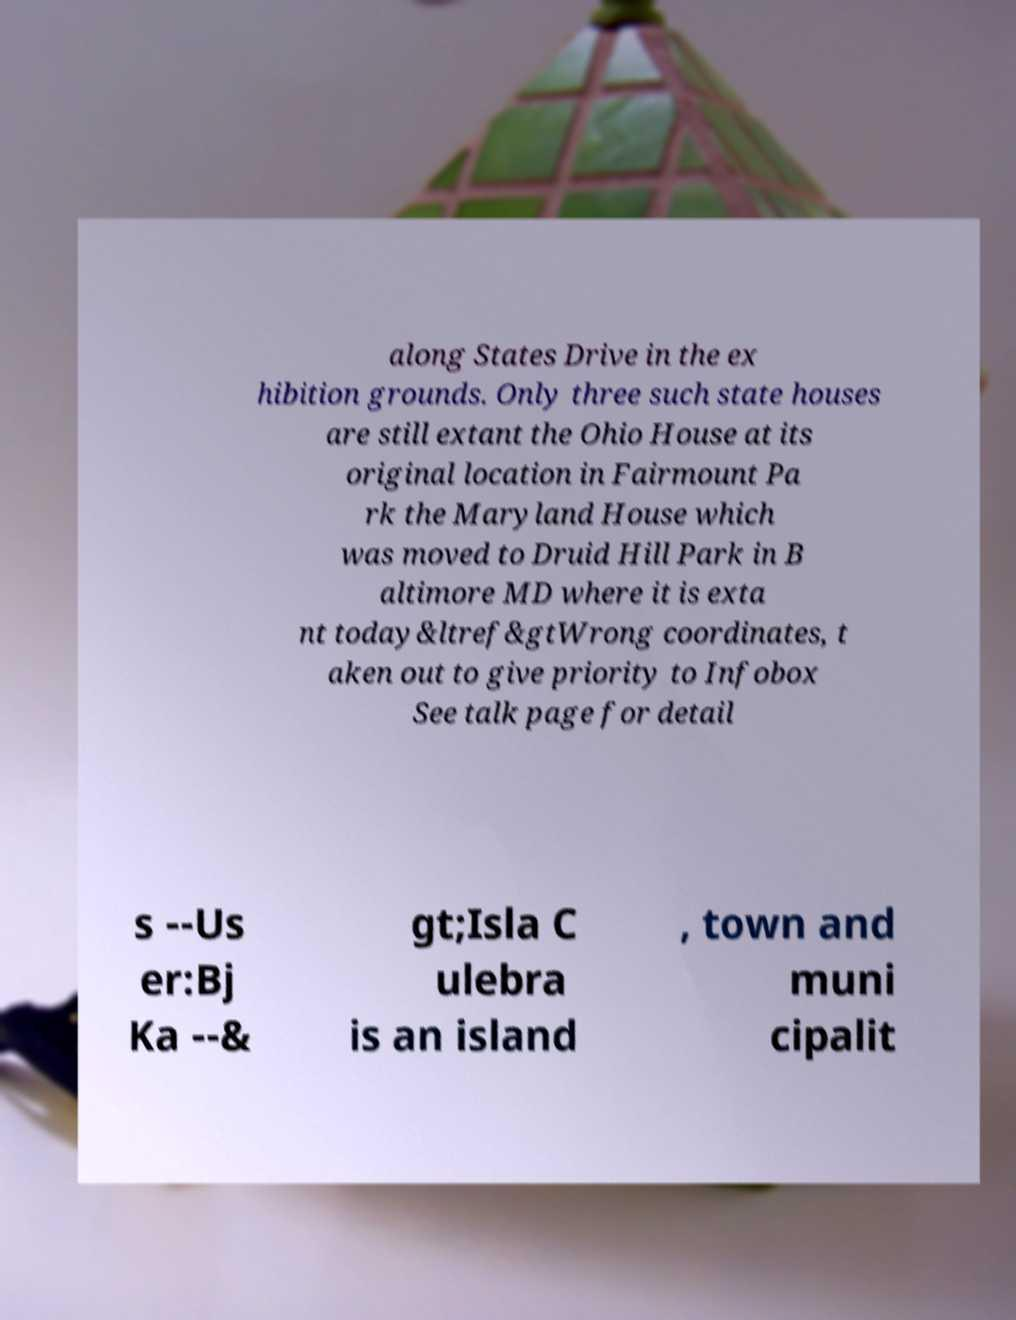For documentation purposes, I need the text within this image transcribed. Could you provide that? along States Drive in the ex hibition grounds. Only three such state houses are still extant the Ohio House at its original location in Fairmount Pa rk the Maryland House which was moved to Druid Hill Park in B altimore MD where it is exta nt today&ltref&gtWrong coordinates, t aken out to give priority to Infobox See talk page for detail s --Us er:Bj Ka --& gt;Isla C ulebra is an island , town and muni cipalit 